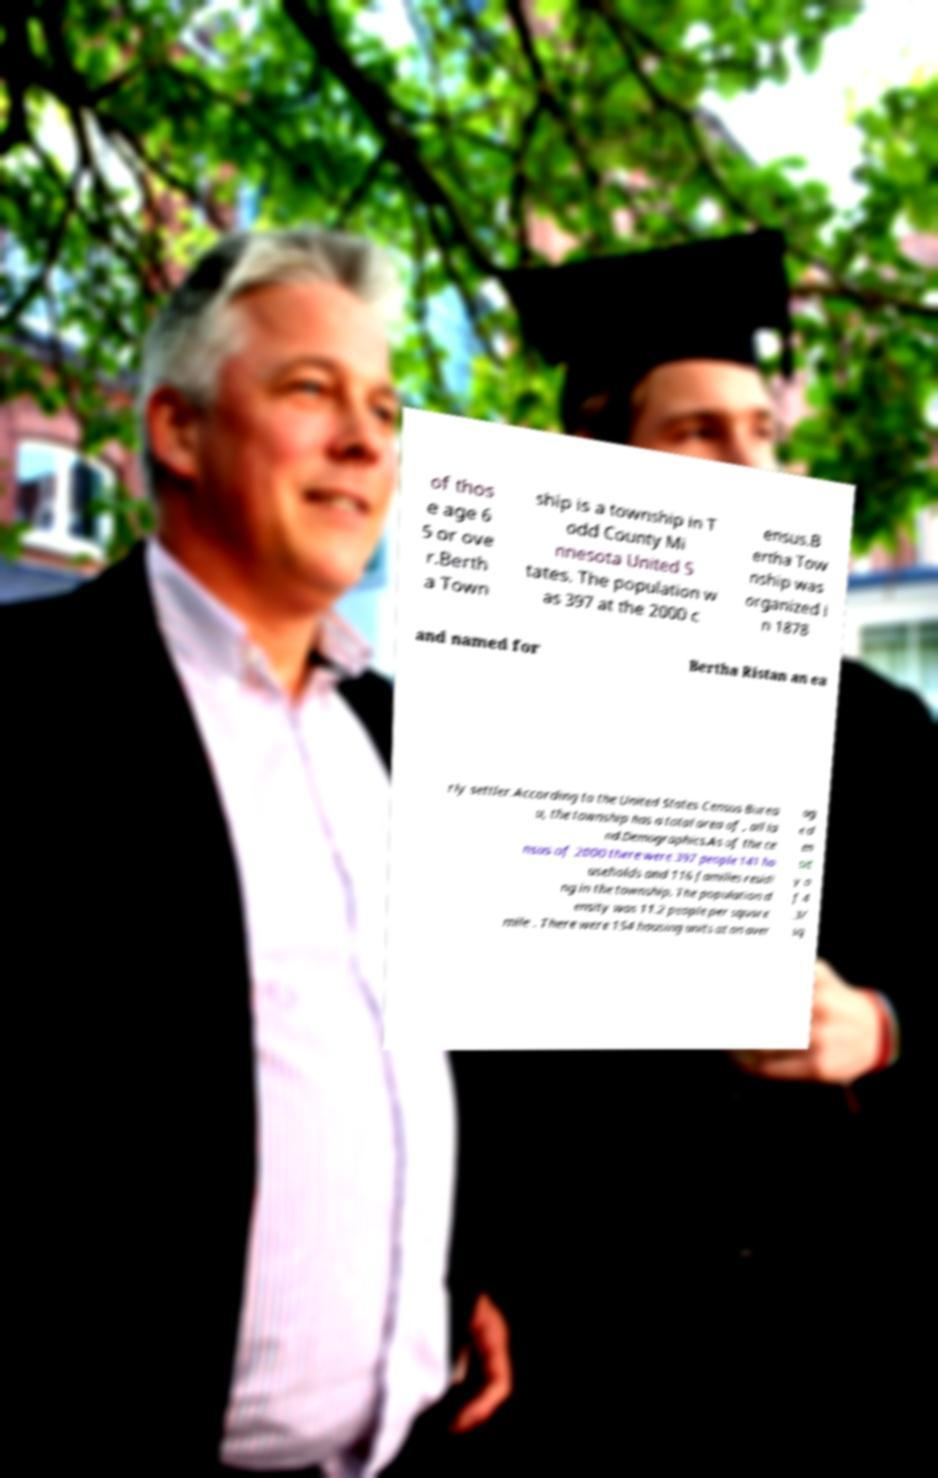Please identify and transcribe the text found in this image. of thos e age 6 5 or ove r.Berth a Town ship is a township in T odd County Mi nnesota United S tates. The population w as 397 at the 2000 c ensus.B ertha Tow nship was organized i n 1878 and named for Bertha Ristan an ea rly settler.According to the United States Census Burea u, the township has a total area of , all la nd.Demographics.As of the ce nsus of 2000 there were 397 people 141 ho useholds and 116 families residi ng in the township. The population d ensity was 11.2 people per square mile . There were 154 housing units at an aver ag e d en sit y o f 4 .3/ sq 